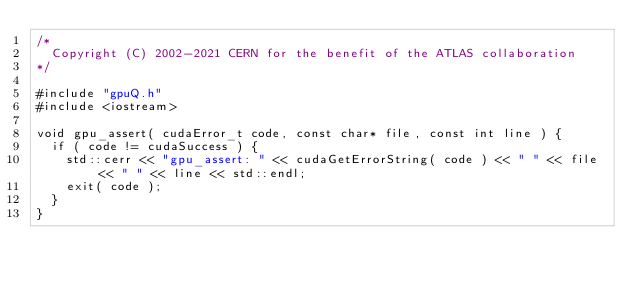Convert code to text. <code><loc_0><loc_0><loc_500><loc_500><_Cuda_>/*
  Copyright (C) 2002-2021 CERN for the benefit of the ATLAS collaboration
*/

#include "gpuQ.h"
#include <iostream>

void gpu_assert( cudaError_t code, const char* file, const int line ) {
  if ( code != cudaSuccess ) {
    std::cerr << "gpu_assert: " << cudaGetErrorString( code ) << " " << file << " " << line << std::endl;
    exit( code );
  }
}
</code> 